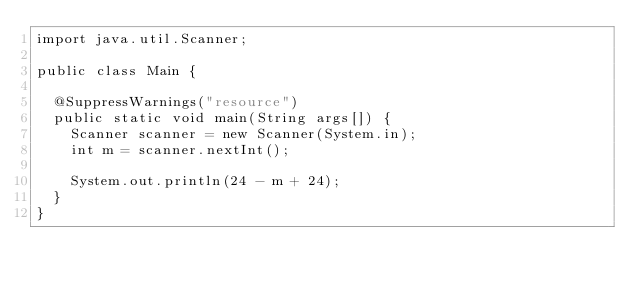Convert code to text. <code><loc_0><loc_0><loc_500><loc_500><_Java_>import java.util.Scanner;

public class Main {

	@SuppressWarnings("resource")
	public static void main(String args[]) {
		Scanner scanner = new Scanner(System.in);
		int m = scanner.nextInt();

		System.out.println(24 - m + 24);
	}
}
</code> 